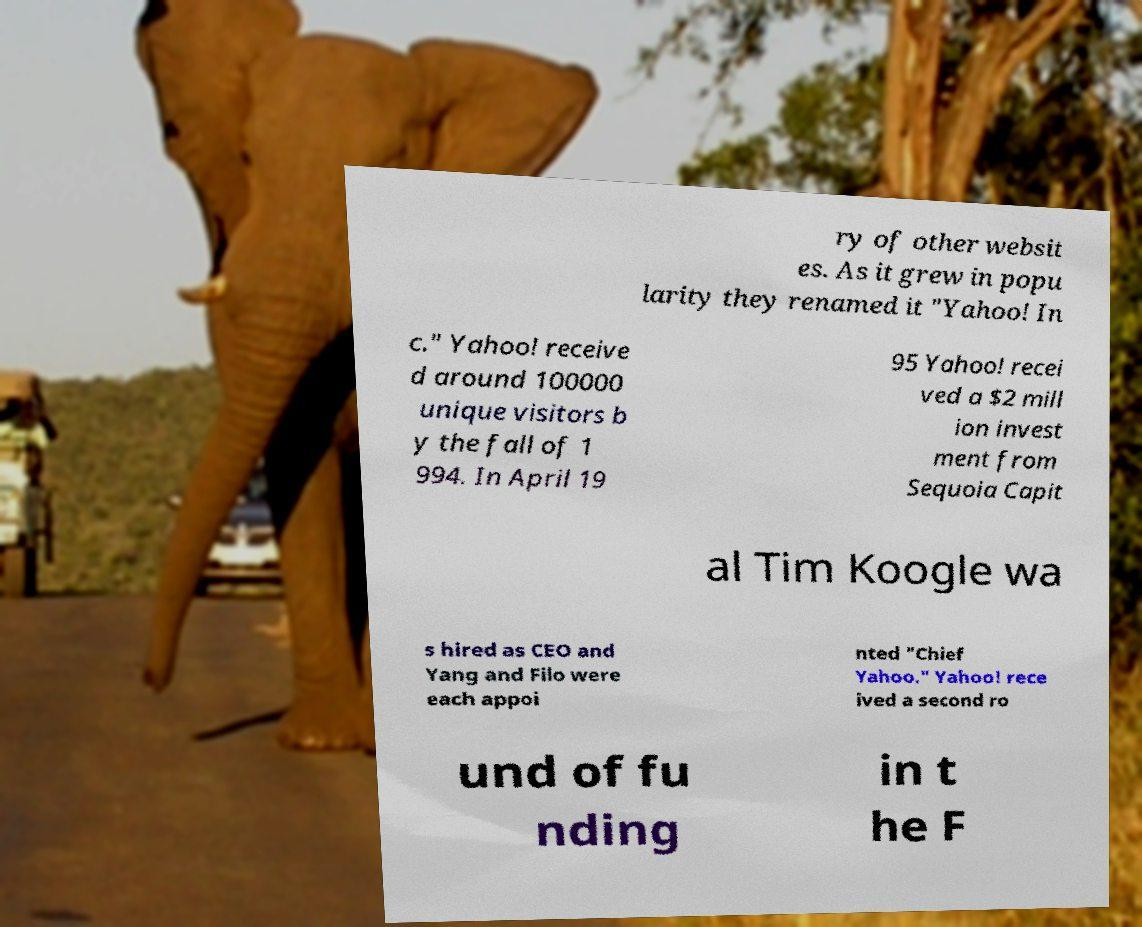Can you read and provide the text displayed in the image?This photo seems to have some interesting text. Can you extract and type it out for me? ry of other websit es. As it grew in popu larity they renamed it "Yahoo! In c." Yahoo! receive d around 100000 unique visitors b y the fall of 1 994. In April 19 95 Yahoo! recei ved a $2 mill ion invest ment from Sequoia Capit al Tim Koogle wa s hired as CEO and Yang and Filo were each appoi nted "Chief Yahoo." Yahoo! rece ived a second ro und of fu nding in t he F 